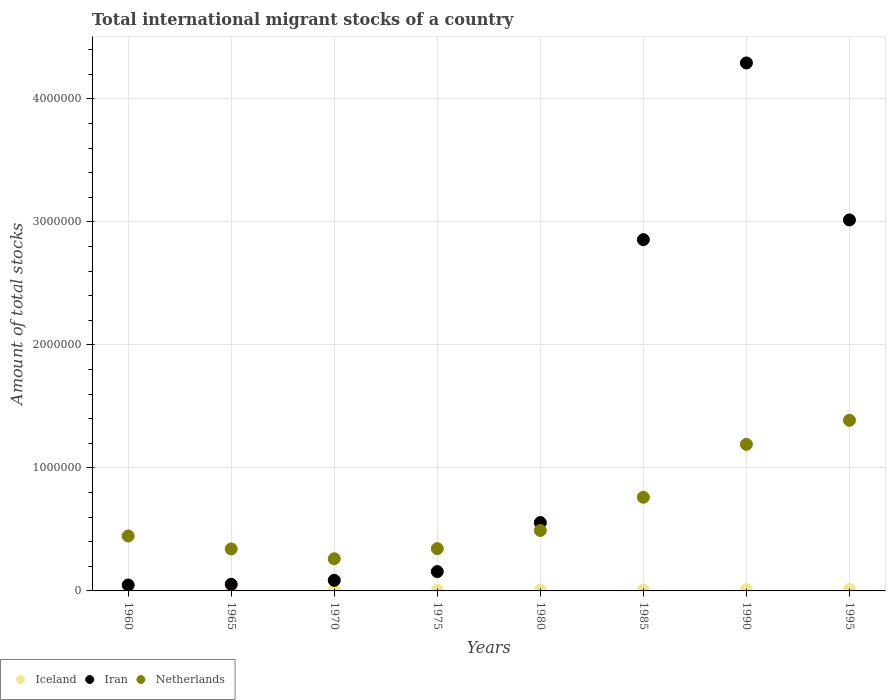What is the amount of total stocks in in Iran in 1995?
Keep it short and to the point. 3.02e+06. Across all years, what is the maximum amount of total stocks in in Iran?
Your response must be concise. 4.29e+06. Across all years, what is the minimum amount of total stocks in in Iran?
Provide a succinct answer. 4.84e+04. What is the total amount of total stocks in in Netherlands in the graph?
Your response must be concise. 5.22e+06. What is the difference between the amount of total stocks in in Netherlands in 1980 and that in 1990?
Make the answer very short. -7.01e+05. What is the difference between the amount of total stocks in in Netherlands in 1975 and the amount of total stocks in in Iran in 1980?
Offer a terse response. -2.12e+05. What is the average amount of total stocks in in Iceland per year?
Give a very brief answer. 6404.88. In the year 1985, what is the difference between the amount of total stocks in in Netherlands and amount of total stocks in in Iceland?
Keep it short and to the point. 7.54e+05. In how many years, is the amount of total stocks in in Iceland greater than 2800000?
Your answer should be very brief. 0. What is the ratio of the amount of total stocks in in Iran in 1975 to that in 1995?
Your answer should be very brief. 0.05. What is the difference between the highest and the second highest amount of total stocks in in Netherlands?
Provide a short and direct response. 1.95e+05. What is the difference between the highest and the lowest amount of total stocks in in Iran?
Offer a terse response. 4.24e+06. Is the sum of the amount of total stocks in in Iran in 1960 and 1995 greater than the maximum amount of total stocks in in Iceland across all years?
Offer a terse response. Yes. Is it the case that in every year, the sum of the amount of total stocks in in Iceland and amount of total stocks in in Netherlands  is greater than the amount of total stocks in in Iran?
Make the answer very short. No. Does the amount of total stocks in in Iceland monotonically increase over the years?
Your answer should be very brief. Yes. Is the amount of total stocks in in Iceland strictly greater than the amount of total stocks in in Iran over the years?
Give a very brief answer. No. How many dotlines are there?
Ensure brevity in your answer.  3. How many years are there in the graph?
Give a very brief answer. 8. Are the values on the major ticks of Y-axis written in scientific E-notation?
Your response must be concise. No. Does the graph contain grids?
Keep it short and to the point. Yes. Where does the legend appear in the graph?
Make the answer very short. Bottom left. How many legend labels are there?
Your answer should be compact. 3. How are the legend labels stacked?
Provide a succinct answer. Horizontal. What is the title of the graph?
Your answer should be very brief. Total international migrant stocks of a country. What is the label or title of the X-axis?
Your answer should be compact. Years. What is the label or title of the Y-axis?
Make the answer very short. Amount of total stocks. What is the Amount of total stocks of Iceland in 1960?
Provide a short and direct response. 3317. What is the Amount of total stocks in Iran in 1960?
Make the answer very short. 4.84e+04. What is the Amount of total stocks of Netherlands in 1960?
Your answer should be compact. 4.47e+05. What is the Amount of total stocks of Iceland in 1965?
Your answer should be compact. 4515. What is the Amount of total stocks in Iran in 1965?
Make the answer very short. 5.38e+04. What is the Amount of total stocks of Netherlands in 1965?
Your response must be concise. 3.42e+05. What is the Amount of total stocks in Iceland in 1970?
Your answer should be very brief. 4914. What is the Amount of total stocks in Iran in 1970?
Your response must be concise. 8.62e+04. What is the Amount of total stocks of Netherlands in 1970?
Keep it short and to the point. 2.61e+05. What is the Amount of total stocks of Iceland in 1975?
Provide a succinct answer. 5279. What is the Amount of total stocks in Iran in 1975?
Provide a succinct answer. 1.57e+05. What is the Amount of total stocks of Netherlands in 1975?
Your answer should be very brief. 3.44e+05. What is the Amount of total stocks of Iceland in 1980?
Offer a very short reply. 5765. What is the Amount of total stocks in Iran in 1980?
Make the answer very short. 5.55e+05. What is the Amount of total stocks in Netherlands in 1980?
Provide a succinct answer. 4.91e+05. What is the Amount of total stocks of Iceland in 1985?
Ensure brevity in your answer.  7098. What is the Amount of total stocks of Iran in 1985?
Offer a very short reply. 2.86e+06. What is the Amount of total stocks of Netherlands in 1985?
Offer a terse response. 7.61e+05. What is the Amount of total stocks of Iceland in 1990?
Give a very brief answer. 9584. What is the Amount of total stocks in Iran in 1990?
Make the answer very short. 4.29e+06. What is the Amount of total stocks of Netherlands in 1990?
Make the answer very short. 1.19e+06. What is the Amount of total stocks of Iceland in 1995?
Keep it short and to the point. 1.08e+04. What is the Amount of total stocks of Iran in 1995?
Provide a succinct answer. 3.02e+06. What is the Amount of total stocks in Netherlands in 1995?
Your answer should be compact. 1.39e+06. Across all years, what is the maximum Amount of total stocks in Iceland?
Offer a very short reply. 1.08e+04. Across all years, what is the maximum Amount of total stocks in Iran?
Give a very brief answer. 4.29e+06. Across all years, what is the maximum Amount of total stocks in Netherlands?
Your answer should be compact. 1.39e+06. Across all years, what is the minimum Amount of total stocks of Iceland?
Offer a very short reply. 3317. Across all years, what is the minimum Amount of total stocks in Iran?
Offer a terse response. 4.84e+04. Across all years, what is the minimum Amount of total stocks of Netherlands?
Your answer should be compact. 2.61e+05. What is the total Amount of total stocks in Iceland in the graph?
Your answer should be compact. 5.12e+04. What is the total Amount of total stocks in Iran in the graph?
Keep it short and to the point. 1.11e+07. What is the total Amount of total stocks in Netherlands in the graph?
Offer a terse response. 5.22e+06. What is the difference between the Amount of total stocks of Iceland in 1960 and that in 1965?
Make the answer very short. -1198. What is the difference between the Amount of total stocks in Iran in 1960 and that in 1965?
Your response must be concise. -5387. What is the difference between the Amount of total stocks in Netherlands in 1960 and that in 1965?
Keep it short and to the point. 1.05e+05. What is the difference between the Amount of total stocks in Iceland in 1960 and that in 1970?
Keep it short and to the point. -1597. What is the difference between the Amount of total stocks of Iran in 1960 and that in 1970?
Provide a succinct answer. -3.78e+04. What is the difference between the Amount of total stocks in Netherlands in 1960 and that in 1970?
Make the answer very short. 1.85e+05. What is the difference between the Amount of total stocks of Iceland in 1960 and that in 1975?
Your response must be concise. -1962. What is the difference between the Amount of total stocks of Iran in 1960 and that in 1975?
Your answer should be very brief. -1.09e+05. What is the difference between the Amount of total stocks in Netherlands in 1960 and that in 1975?
Ensure brevity in your answer.  1.03e+05. What is the difference between the Amount of total stocks of Iceland in 1960 and that in 1980?
Offer a very short reply. -2448. What is the difference between the Amount of total stocks in Iran in 1960 and that in 1980?
Your answer should be very brief. -5.07e+05. What is the difference between the Amount of total stocks in Netherlands in 1960 and that in 1980?
Your response must be concise. -4.44e+04. What is the difference between the Amount of total stocks in Iceland in 1960 and that in 1985?
Your response must be concise. -3781. What is the difference between the Amount of total stocks of Iran in 1960 and that in 1985?
Provide a succinct answer. -2.81e+06. What is the difference between the Amount of total stocks in Netherlands in 1960 and that in 1985?
Your answer should be very brief. -3.15e+05. What is the difference between the Amount of total stocks in Iceland in 1960 and that in 1990?
Offer a very short reply. -6267. What is the difference between the Amount of total stocks in Iran in 1960 and that in 1990?
Ensure brevity in your answer.  -4.24e+06. What is the difference between the Amount of total stocks in Netherlands in 1960 and that in 1990?
Provide a succinct answer. -7.45e+05. What is the difference between the Amount of total stocks in Iceland in 1960 and that in 1995?
Keep it short and to the point. -7450. What is the difference between the Amount of total stocks in Iran in 1960 and that in 1995?
Keep it short and to the point. -2.97e+06. What is the difference between the Amount of total stocks in Netherlands in 1960 and that in 1995?
Give a very brief answer. -9.40e+05. What is the difference between the Amount of total stocks in Iceland in 1965 and that in 1970?
Your answer should be compact. -399. What is the difference between the Amount of total stocks of Iran in 1965 and that in 1970?
Offer a terse response. -3.24e+04. What is the difference between the Amount of total stocks of Netherlands in 1965 and that in 1970?
Keep it short and to the point. 8.03e+04. What is the difference between the Amount of total stocks in Iceland in 1965 and that in 1975?
Your response must be concise. -764. What is the difference between the Amount of total stocks in Iran in 1965 and that in 1975?
Provide a short and direct response. -1.03e+05. What is the difference between the Amount of total stocks of Netherlands in 1965 and that in 1975?
Offer a terse response. -2069. What is the difference between the Amount of total stocks in Iceland in 1965 and that in 1980?
Give a very brief answer. -1250. What is the difference between the Amount of total stocks of Iran in 1965 and that in 1980?
Ensure brevity in your answer.  -5.02e+05. What is the difference between the Amount of total stocks of Netherlands in 1965 and that in 1980?
Make the answer very short. -1.49e+05. What is the difference between the Amount of total stocks in Iceland in 1965 and that in 1985?
Provide a short and direct response. -2583. What is the difference between the Amount of total stocks in Iran in 1965 and that in 1985?
Your answer should be very brief. -2.80e+06. What is the difference between the Amount of total stocks of Netherlands in 1965 and that in 1985?
Ensure brevity in your answer.  -4.20e+05. What is the difference between the Amount of total stocks in Iceland in 1965 and that in 1990?
Your answer should be very brief. -5069. What is the difference between the Amount of total stocks in Iran in 1965 and that in 1990?
Your answer should be very brief. -4.24e+06. What is the difference between the Amount of total stocks in Netherlands in 1965 and that in 1990?
Offer a terse response. -8.50e+05. What is the difference between the Amount of total stocks in Iceland in 1965 and that in 1995?
Make the answer very short. -6252. What is the difference between the Amount of total stocks in Iran in 1965 and that in 1995?
Give a very brief answer. -2.96e+06. What is the difference between the Amount of total stocks of Netherlands in 1965 and that in 1995?
Provide a succinct answer. -1.05e+06. What is the difference between the Amount of total stocks in Iceland in 1970 and that in 1975?
Offer a very short reply. -365. What is the difference between the Amount of total stocks of Iran in 1970 and that in 1975?
Offer a very short reply. -7.10e+04. What is the difference between the Amount of total stocks of Netherlands in 1970 and that in 1975?
Offer a terse response. -8.24e+04. What is the difference between the Amount of total stocks of Iceland in 1970 and that in 1980?
Your answer should be compact. -851. What is the difference between the Amount of total stocks in Iran in 1970 and that in 1980?
Your answer should be compact. -4.69e+05. What is the difference between the Amount of total stocks in Netherlands in 1970 and that in 1980?
Keep it short and to the point. -2.30e+05. What is the difference between the Amount of total stocks of Iceland in 1970 and that in 1985?
Ensure brevity in your answer.  -2184. What is the difference between the Amount of total stocks in Iran in 1970 and that in 1985?
Provide a short and direct response. -2.77e+06. What is the difference between the Amount of total stocks of Netherlands in 1970 and that in 1985?
Provide a succinct answer. -5.00e+05. What is the difference between the Amount of total stocks in Iceland in 1970 and that in 1990?
Provide a short and direct response. -4670. What is the difference between the Amount of total stocks in Iran in 1970 and that in 1990?
Offer a very short reply. -4.21e+06. What is the difference between the Amount of total stocks in Netherlands in 1970 and that in 1990?
Your answer should be very brief. -9.30e+05. What is the difference between the Amount of total stocks of Iceland in 1970 and that in 1995?
Ensure brevity in your answer.  -5853. What is the difference between the Amount of total stocks in Iran in 1970 and that in 1995?
Keep it short and to the point. -2.93e+06. What is the difference between the Amount of total stocks in Netherlands in 1970 and that in 1995?
Ensure brevity in your answer.  -1.13e+06. What is the difference between the Amount of total stocks of Iceland in 1975 and that in 1980?
Your answer should be very brief. -486. What is the difference between the Amount of total stocks of Iran in 1975 and that in 1980?
Offer a terse response. -3.98e+05. What is the difference between the Amount of total stocks in Netherlands in 1975 and that in 1980?
Offer a terse response. -1.47e+05. What is the difference between the Amount of total stocks in Iceland in 1975 and that in 1985?
Your response must be concise. -1819. What is the difference between the Amount of total stocks of Iran in 1975 and that in 1985?
Give a very brief answer. -2.70e+06. What is the difference between the Amount of total stocks of Netherlands in 1975 and that in 1985?
Your response must be concise. -4.18e+05. What is the difference between the Amount of total stocks of Iceland in 1975 and that in 1990?
Offer a very short reply. -4305. What is the difference between the Amount of total stocks in Iran in 1975 and that in 1990?
Offer a terse response. -4.13e+06. What is the difference between the Amount of total stocks in Netherlands in 1975 and that in 1990?
Ensure brevity in your answer.  -8.48e+05. What is the difference between the Amount of total stocks in Iceland in 1975 and that in 1995?
Offer a very short reply. -5488. What is the difference between the Amount of total stocks of Iran in 1975 and that in 1995?
Provide a succinct answer. -2.86e+06. What is the difference between the Amount of total stocks in Netherlands in 1975 and that in 1995?
Your answer should be very brief. -1.04e+06. What is the difference between the Amount of total stocks in Iceland in 1980 and that in 1985?
Give a very brief answer. -1333. What is the difference between the Amount of total stocks in Iran in 1980 and that in 1985?
Keep it short and to the point. -2.30e+06. What is the difference between the Amount of total stocks of Netherlands in 1980 and that in 1985?
Ensure brevity in your answer.  -2.70e+05. What is the difference between the Amount of total stocks of Iceland in 1980 and that in 1990?
Keep it short and to the point. -3819. What is the difference between the Amount of total stocks in Iran in 1980 and that in 1990?
Offer a terse response. -3.74e+06. What is the difference between the Amount of total stocks in Netherlands in 1980 and that in 1990?
Offer a very short reply. -7.01e+05. What is the difference between the Amount of total stocks of Iceland in 1980 and that in 1995?
Your answer should be compact. -5002. What is the difference between the Amount of total stocks in Iran in 1980 and that in 1995?
Offer a terse response. -2.46e+06. What is the difference between the Amount of total stocks of Netherlands in 1980 and that in 1995?
Provide a succinct answer. -8.96e+05. What is the difference between the Amount of total stocks in Iceland in 1985 and that in 1990?
Your answer should be very brief. -2486. What is the difference between the Amount of total stocks in Iran in 1985 and that in 1990?
Your answer should be compact. -1.44e+06. What is the difference between the Amount of total stocks of Netherlands in 1985 and that in 1990?
Your answer should be compact. -4.30e+05. What is the difference between the Amount of total stocks in Iceland in 1985 and that in 1995?
Make the answer very short. -3669. What is the difference between the Amount of total stocks of Iran in 1985 and that in 1995?
Ensure brevity in your answer.  -1.60e+05. What is the difference between the Amount of total stocks of Netherlands in 1985 and that in 1995?
Your answer should be very brief. -6.25e+05. What is the difference between the Amount of total stocks in Iceland in 1990 and that in 1995?
Keep it short and to the point. -1183. What is the difference between the Amount of total stocks in Iran in 1990 and that in 1995?
Keep it short and to the point. 1.28e+06. What is the difference between the Amount of total stocks of Netherlands in 1990 and that in 1995?
Give a very brief answer. -1.95e+05. What is the difference between the Amount of total stocks of Iceland in 1960 and the Amount of total stocks of Iran in 1965?
Make the answer very short. -5.04e+04. What is the difference between the Amount of total stocks of Iceland in 1960 and the Amount of total stocks of Netherlands in 1965?
Your answer should be compact. -3.38e+05. What is the difference between the Amount of total stocks of Iran in 1960 and the Amount of total stocks of Netherlands in 1965?
Your answer should be compact. -2.93e+05. What is the difference between the Amount of total stocks of Iceland in 1960 and the Amount of total stocks of Iran in 1970?
Your answer should be very brief. -8.28e+04. What is the difference between the Amount of total stocks of Iceland in 1960 and the Amount of total stocks of Netherlands in 1970?
Your answer should be very brief. -2.58e+05. What is the difference between the Amount of total stocks in Iran in 1960 and the Amount of total stocks in Netherlands in 1970?
Give a very brief answer. -2.13e+05. What is the difference between the Amount of total stocks in Iceland in 1960 and the Amount of total stocks in Iran in 1975?
Make the answer very short. -1.54e+05. What is the difference between the Amount of total stocks in Iceland in 1960 and the Amount of total stocks in Netherlands in 1975?
Your answer should be very brief. -3.40e+05. What is the difference between the Amount of total stocks of Iran in 1960 and the Amount of total stocks of Netherlands in 1975?
Offer a very short reply. -2.95e+05. What is the difference between the Amount of total stocks of Iceland in 1960 and the Amount of total stocks of Iran in 1980?
Provide a short and direct response. -5.52e+05. What is the difference between the Amount of total stocks in Iceland in 1960 and the Amount of total stocks in Netherlands in 1980?
Give a very brief answer. -4.88e+05. What is the difference between the Amount of total stocks of Iran in 1960 and the Amount of total stocks of Netherlands in 1980?
Your answer should be compact. -4.43e+05. What is the difference between the Amount of total stocks of Iceland in 1960 and the Amount of total stocks of Iran in 1985?
Your answer should be very brief. -2.85e+06. What is the difference between the Amount of total stocks in Iceland in 1960 and the Amount of total stocks in Netherlands in 1985?
Ensure brevity in your answer.  -7.58e+05. What is the difference between the Amount of total stocks of Iran in 1960 and the Amount of total stocks of Netherlands in 1985?
Your response must be concise. -7.13e+05. What is the difference between the Amount of total stocks in Iceland in 1960 and the Amount of total stocks in Iran in 1990?
Your answer should be very brief. -4.29e+06. What is the difference between the Amount of total stocks of Iceland in 1960 and the Amount of total stocks of Netherlands in 1990?
Offer a terse response. -1.19e+06. What is the difference between the Amount of total stocks in Iran in 1960 and the Amount of total stocks in Netherlands in 1990?
Provide a short and direct response. -1.14e+06. What is the difference between the Amount of total stocks in Iceland in 1960 and the Amount of total stocks in Iran in 1995?
Your answer should be very brief. -3.01e+06. What is the difference between the Amount of total stocks in Iceland in 1960 and the Amount of total stocks in Netherlands in 1995?
Provide a short and direct response. -1.38e+06. What is the difference between the Amount of total stocks in Iran in 1960 and the Amount of total stocks in Netherlands in 1995?
Offer a very short reply. -1.34e+06. What is the difference between the Amount of total stocks of Iceland in 1965 and the Amount of total stocks of Iran in 1970?
Make the answer very short. -8.16e+04. What is the difference between the Amount of total stocks in Iceland in 1965 and the Amount of total stocks in Netherlands in 1970?
Ensure brevity in your answer.  -2.57e+05. What is the difference between the Amount of total stocks of Iran in 1965 and the Amount of total stocks of Netherlands in 1970?
Your answer should be very brief. -2.08e+05. What is the difference between the Amount of total stocks in Iceland in 1965 and the Amount of total stocks in Iran in 1975?
Offer a terse response. -1.53e+05. What is the difference between the Amount of total stocks of Iceland in 1965 and the Amount of total stocks of Netherlands in 1975?
Give a very brief answer. -3.39e+05. What is the difference between the Amount of total stocks of Iran in 1965 and the Amount of total stocks of Netherlands in 1975?
Your response must be concise. -2.90e+05. What is the difference between the Amount of total stocks of Iceland in 1965 and the Amount of total stocks of Iran in 1980?
Your answer should be compact. -5.51e+05. What is the difference between the Amount of total stocks in Iceland in 1965 and the Amount of total stocks in Netherlands in 1980?
Your answer should be very brief. -4.86e+05. What is the difference between the Amount of total stocks of Iran in 1965 and the Amount of total stocks of Netherlands in 1980?
Provide a short and direct response. -4.37e+05. What is the difference between the Amount of total stocks of Iceland in 1965 and the Amount of total stocks of Iran in 1985?
Your answer should be very brief. -2.85e+06. What is the difference between the Amount of total stocks in Iceland in 1965 and the Amount of total stocks in Netherlands in 1985?
Provide a succinct answer. -7.57e+05. What is the difference between the Amount of total stocks of Iran in 1965 and the Amount of total stocks of Netherlands in 1985?
Your answer should be compact. -7.08e+05. What is the difference between the Amount of total stocks in Iceland in 1965 and the Amount of total stocks in Iran in 1990?
Your answer should be very brief. -4.29e+06. What is the difference between the Amount of total stocks of Iceland in 1965 and the Amount of total stocks of Netherlands in 1990?
Provide a succinct answer. -1.19e+06. What is the difference between the Amount of total stocks of Iran in 1965 and the Amount of total stocks of Netherlands in 1990?
Give a very brief answer. -1.14e+06. What is the difference between the Amount of total stocks of Iceland in 1965 and the Amount of total stocks of Iran in 1995?
Offer a terse response. -3.01e+06. What is the difference between the Amount of total stocks in Iceland in 1965 and the Amount of total stocks in Netherlands in 1995?
Your response must be concise. -1.38e+06. What is the difference between the Amount of total stocks in Iran in 1965 and the Amount of total stocks in Netherlands in 1995?
Provide a succinct answer. -1.33e+06. What is the difference between the Amount of total stocks in Iceland in 1970 and the Amount of total stocks in Iran in 1975?
Keep it short and to the point. -1.52e+05. What is the difference between the Amount of total stocks in Iceland in 1970 and the Amount of total stocks in Netherlands in 1975?
Provide a short and direct response. -3.39e+05. What is the difference between the Amount of total stocks of Iran in 1970 and the Amount of total stocks of Netherlands in 1975?
Make the answer very short. -2.58e+05. What is the difference between the Amount of total stocks in Iceland in 1970 and the Amount of total stocks in Iran in 1980?
Your answer should be very brief. -5.51e+05. What is the difference between the Amount of total stocks in Iceland in 1970 and the Amount of total stocks in Netherlands in 1980?
Provide a short and direct response. -4.86e+05. What is the difference between the Amount of total stocks in Iran in 1970 and the Amount of total stocks in Netherlands in 1980?
Your answer should be very brief. -4.05e+05. What is the difference between the Amount of total stocks in Iceland in 1970 and the Amount of total stocks in Iran in 1985?
Your response must be concise. -2.85e+06. What is the difference between the Amount of total stocks in Iceland in 1970 and the Amount of total stocks in Netherlands in 1985?
Ensure brevity in your answer.  -7.57e+05. What is the difference between the Amount of total stocks of Iran in 1970 and the Amount of total stocks of Netherlands in 1985?
Your answer should be very brief. -6.75e+05. What is the difference between the Amount of total stocks of Iceland in 1970 and the Amount of total stocks of Iran in 1990?
Keep it short and to the point. -4.29e+06. What is the difference between the Amount of total stocks in Iceland in 1970 and the Amount of total stocks in Netherlands in 1990?
Your answer should be compact. -1.19e+06. What is the difference between the Amount of total stocks of Iran in 1970 and the Amount of total stocks of Netherlands in 1990?
Your response must be concise. -1.11e+06. What is the difference between the Amount of total stocks in Iceland in 1970 and the Amount of total stocks in Iran in 1995?
Make the answer very short. -3.01e+06. What is the difference between the Amount of total stocks in Iceland in 1970 and the Amount of total stocks in Netherlands in 1995?
Provide a short and direct response. -1.38e+06. What is the difference between the Amount of total stocks in Iran in 1970 and the Amount of total stocks in Netherlands in 1995?
Your answer should be compact. -1.30e+06. What is the difference between the Amount of total stocks in Iceland in 1975 and the Amount of total stocks in Iran in 1980?
Offer a terse response. -5.50e+05. What is the difference between the Amount of total stocks of Iceland in 1975 and the Amount of total stocks of Netherlands in 1980?
Provide a short and direct response. -4.86e+05. What is the difference between the Amount of total stocks of Iran in 1975 and the Amount of total stocks of Netherlands in 1980?
Provide a short and direct response. -3.34e+05. What is the difference between the Amount of total stocks of Iceland in 1975 and the Amount of total stocks of Iran in 1985?
Keep it short and to the point. -2.85e+06. What is the difference between the Amount of total stocks of Iceland in 1975 and the Amount of total stocks of Netherlands in 1985?
Provide a succinct answer. -7.56e+05. What is the difference between the Amount of total stocks in Iran in 1975 and the Amount of total stocks in Netherlands in 1985?
Make the answer very short. -6.04e+05. What is the difference between the Amount of total stocks of Iceland in 1975 and the Amount of total stocks of Iran in 1990?
Ensure brevity in your answer.  -4.29e+06. What is the difference between the Amount of total stocks in Iceland in 1975 and the Amount of total stocks in Netherlands in 1990?
Give a very brief answer. -1.19e+06. What is the difference between the Amount of total stocks in Iran in 1975 and the Amount of total stocks in Netherlands in 1990?
Your answer should be very brief. -1.03e+06. What is the difference between the Amount of total stocks in Iceland in 1975 and the Amount of total stocks in Iran in 1995?
Your answer should be compact. -3.01e+06. What is the difference between the Amount of total stocks in Iceland in 1975 and the Amount of total stocks in Netherlands in 1995?
Your answer should be very brief. -1.38e+06. What is the difference between the Amount of total stocks of Iran in 1975 and the Amount of total stocks of Netherlands in 1995?
Keep it short and to the point. -1.23e+06. What is the difference between the Amount of total stocks in Iceland in 1980 and the Amount of total stocks in Iran in 1985?
Make the answer very short. -2.85e+06. What is the difference between the Amount of total stocks of Iceland in 1980 and the Amount of total stocks of Netherlands in 1985?
Ensure brevity in your answer.  -7.56e+05. What is the difference between the Amount of total stocks of Iran in 1980 and the Amount of total stocks of Netherlands in 1985?
Your answer should be very brief. -2.06e+05. What is the difference between the Amount of total stocks in Iceland in 1980 and the Amount of total stocks in Iran in 1990?
Provide a succinct answer. -4.29e+06. What is the difference between the Amount of total stocks of Iceland in 1980 and the Amount of total stocks of Netherlands in 1990?
Give a very brief answer. -1.19e+06. What is the difference between the Amount of total stocks in Iran in 1980 and the Amount of total stocks in Netherlands in 1990?
Ensure brevity in your answer.  -6.36e+05. What is the difference between the Amount of total stocks of Iceland in 1980 and the Amount of total stocks of Iran in 1995?
Provide a short and direct response. -3.01e+06. What is the difference between the Amount of total stocks of Iceland in 1980 and the Amount of total stocks of Netherlands in 1995?
Give a very brief answer. -1.38e+06. What is the difference between the Amount of total stocks in Iran in 1980 and the Amount of total stocks in Netherlands in 1995?
Make the answer very short. -8.31e+05. What is the difference between the Amount of total stocks in Iceland in 1985 and the Amount of total stocks in Iran in 1990?
Your answer should be compact. -4.28e+06. What is the difference between the Amount of total stocks in Iceland in 1985 and the Amount of total stocks in Netherlands in 1990?
Provide a short and direct response. -1.18e+06. What is the difference between the Amount of total stocks in Iran in 1985 and the Amount of total stocks in Netherlands in 1990?
Ensure brevity in your answer.  1.66e+06. What is the difference between the Amount of total stocks in Iceland in 1985 and the Amount of total stocks in Iran in 1995?
Keep it short and to the point. -3.01e+06. What is the difference between the Amount of total stocks of Iceland in 1985 and the Amount of total stocks of Netherlands in 1995?
Keep it short and to the point. -1.38e+06. What is the difference between the Amount of total stocks in Iran in 1985 and the Amount of total stocks in Netherlands in 1995?
Ensure brevity in your answer.  1.47e+06. What is the difference between the Amount of total stocks of Iceland in 1990 and the Amount of total stocks of Iran in 1995?
Keep it short and to the point. -3.01e+06. What is the difference between the Amount of total stocks of Iceland in 1990 and the Amount of total stocks of Netherlands in 1995?
Keep it short and to the point. -1.38e+06. What is the difference between the Amount of total stocks of Iran in 1990 and the Amount of total stocks of Netherlands in 1995?
Provide a short and direct response. 2.90e+06. What is the average Amount of total stocks in Iceland per year?
Provide a short and direct response. 6404.88. What is the average Amount of total stocks of Iran per year?
Make the answer very short. 1.38e+06. What is the average Amount of total stocks of Netherlands per year?
Make the answer very short. 6.53e+05. In the year 1960, what is the difference between the Amount of total stocks of Iceland and Amount of total stocks of Iran?
Provide a succinct answer. -4.51e+04. In the year 1960, what is the difference between the Amount of total stocks in Iceland and Amount of total stocks in Netherlands?
Your response must be concise. -4.43e+05. In the year 1960, what is the difference between the Amount of total stocks in Iran and Amount of total stocks in Netherlands?
Provide a short and direct response. -3.98e+05. In the year 1965, what is the difference between the Amount of total stocks in Iceland and Amount of total stocks in Iran?
Offer a terse response. -4.92e+04. In the year 1965, what is the difference between the Amount of total stocks in Iceland and Amount of total stocks in Netherlands?
Your answer should be compact. -3.37e+05. In the year 1965, what is the difference between the Amount of total stocks of Iran and Amount of total stocks of Netherlands?
Offer a terse response. -2.88e+05. In the year 1970, what is the difference between the Amount of total stocks in Iceland and Amount of total stocks in Iran?
Your answer should be compact. -8.13e+04. In the year 1970, what is the difference between the Amount of total stocks of Iceland and Amount of total stocks of Netherlands?
Keep it short and to the point. -2.56e+05. In the year 1970, what is the difference between the Amount of total stocks of Iran and Amount of total stocks of Netherlands?
Ensure brevity in your answer.  -1.75e+05. In the year 1975, what is the difference between the Amount of total stocks in Iceland and Amount of total stocks in Iran?
Offer a terse response. -1.52e+05. In the year 1975, what is the difference between the Amount of total stocks in Iceland and Amount of total stocks in Netherlands?
Provide a short and direct response. -3.38e+05. In the year 1975, what is the difference between the Amount of total stocks of Iran and Amount of total stocks of Netherlands?
Make the answer very short. -1.87e+05. In the year 1980, what is the difference between the Amount of total stocks of Iceland and Amount of total stocks of Iran?
Offer a terse response. -5.50e+05. In the year 1980, what is the difference between the Amount of total stocks of Iceland and Amount of total stocks of Netherlands?
Your response must be concise. -4.85e+05. In the year 1980, what is the difference between the Amount of total stocks of Iran and Amount of total stocks of Netherlands?
Provide a succinct answer. 6.45e+04. In the year 1985, what is the difference between the Amount of total stocks in Iceland and Amount of total stocks in Iran?
Provide a short and direct response. -2.85e+06. In the year 1985, what is the difference between the Amount of total stocks of Iceland and Amount of total stocks of Netherlands?
Offer a very short reply. -7.54e+05. In the year 1985, what is the difference between the Amount of total stocks of Iran and Amount of total stocks of Netherlands?
Offer a terse response. 2.09e+06. In the year 1990, what is the difference between the Amount of total stocks of Iceland and Amount of total stocks of Iran?
Keep it short and to the point. -4.28e+06. In the year 1990, what is the difference between the Amount of total stocks of Iceland and Amount of total stocks of Netherlands?
Keep it short and to the point. -1.18e+06. In the year 1990, what is the difference between the Amount of total stocks in Iran and Amount of total stocks in Netherlands?
Your answer should be compact. 3.10e+06. In the year 1995, what is the difference between the Amount of total stocks in Iceland and Amount of total stocks in Iran?
Offer a terse response. -3.00e+06. In the year 1995, what is the difference between the Amount of total stocks of Iceland and Amount of total stocks of Netherlands?
Provide a succinct answer. -1.38e+06. In the year 1995, what is the difference between the Amount of total stocks in Iran and Amount of total stocks in Netherlands?
Ensure brevity in your answer.  1.63e+06. What is the ratio of the Amount of total stocks of Iceland in 1960 to that in 1965?
Ensure brevity in your answer.  0.73. What is the ratio of the Amount of total stocks of Iran in 1960 to that in 1965?
Your response must be concise. 0.9. What is the ratio of the Amount of total stocks of Netherlands in 1960 to that in 1965?
Keep it short and to the point. 1.31. What is the ratio of the Amount of total stocks of Iceland in 1960 to that in 1970?
Provide a short and direct response. 0.68. What is the ratio of the Amount of total stocks of Iran in 1960 to that in 1970?
Provide a short and direct response. 0.56. What is the ratio of the Amount of total stocks of Netherlands in 1960 to that in 1970?
Give a very brief answer. 1.71. What is the ratio of the Amount of total stocks of Iceland in 1960 to that in 1975?
Provide a succinct answer. 0.63. What is the ratio of the Amount of total stocks in Iran in 1960 to that in 1975?
Ensure brevity in your answer.  0.31. What is the ratio of the Amount of total stocks in Netherlands in 1960 to that in 1975?
Make the answer very short. 1.3. What is the ratio of the Amount of total stocks in Iceland in 1960 to that in 1980?
Your answer should be very brief. 0.58. What is the ratio of the Amount of total stocks of Iran in 1960 to that in 1980?
Your response must be concise. 0.09. What is the ratio of the Amount of total stocks in Netherlands in 1960 to that in 1980?
Keep it short and to the point. 0.91. What is the ratio of the Amount of total stocks of Iceland in 1960 to that in 1985?
Make the answer very short. 0.47. What is the ratio of the Amount of total stocks in Iran in 1960 to that in 1985?
Your answer should be very brief. 0.02. What is the ratio of the Amount of total stocks of Netherlands in 1960 to that in 1985?
Your answer should be very brief. 0.59. What is the ratio of the Amount of total stocks of Iceland in 1960 to that in 1990?
Provide a short and direct response. 0.35. What is the ratio of the Amount of total stocks in Iran in 1960 to that in 1990?
Provide a succinct answer. 0.01. What is the ratio of the Amount of total stocks in Netherlands in 1960 to that in 1990?
Make the answer very short. 0.37. What is the ratio of the Amount of total stocks in Iceland in 1960 to that in 1995?
Ensure brevity in your answer.  0.31. What is the ratio of the Amount of total stocks in Iran in 1960 to that in 1995?
Offer a terse response. 0.02. What is the ratio of the Amount of total stocks in Netherlands in 1960 to that in 1995?
Your answer should be compact. 0.32. What is the ratio of the Amount of total stocks of Iceland in 1965 to that in 1970?
Your answer should be compact. 0.92. What is the ratio of the Amount of total stocks of Iran in 1965 to that in 1970?
Keep it short and to the point. 0.62. What is the ratio of the Amount of total stocks of Netherlands in 1965 to that in 1970?
Your response must be concise. 1.31. What is the ratio of the Amount of total stocks of Iceland in 1965 to that in 1975?
Your answer should be very brief. 0.86. What is the ratio of the Amount of total stocks of Iran in 1965 to that in 1975?
Provide a succinct answer. 0.34. What is the ratio of the Amount of total stocks in Netherlands in 1965 to that in 1975?
Your response must be concise. 0.99. What is the ratio of the Amount of total stocks of Iceland in 1965 to that in 1980?
Offer a terse response. 0.78. What is the ratio of the Amount of total stocks in Iran in 1965 to that in 1980?
Offer a terse response. 0.1. What is the ratio of the Amount of total stocks in Netherlands in 1965 to that in 1980?
Keep it short and to the point. 0.7. What is the ratio of the Amount of total stocks of Iceland in 1965 to that in 1985?
Ensure brevity in your answer.  0.64. What is the ratio of the Amount of total stocks in Iran in 1965 to that in 1985?
Provide a succinct answer. 0.02. What is the ratio of the Amount of total stocks in Netherlands in 1965 to that in 1985?
Your response must be concise. 0.45. What is the ratio of the Amount of total stocks of Iceland in 1965 to that in 1990?
Keep it short and to the point. 0.47. What is the ratio of the Amount of total stocks in Iran in 1965 to that in 1990?
Give a very brief answer. 0.01. What is the ratio of the Amount of total stocks in Netherlands in 1965 to that in 1990?
Ensure brevity in your answer.  0.29. What is the ratio of the Amount of total stocks in Iceland in 1965 to that in 1995?
Offer a very short reply. 0.42. What is the ratio of the Amount of total stocks of Iran in 1965 to that in 1995?
Keep it short and to the point. 0.02. What is the ratio of the Amount of total stocks of Netherlands in 1965 to that in 1995?
Give a very brief answer. 0.25. What is the ratio of the Amount of total stocks in Iceland in 1970 to that in 1975?
Offer a terse response. 0.93. What is the ratio of the Amount of total stocks of Iran in 1970 to that in 1975?
Provide a succinct answer. 0.55. What is the ratio of the Amount of total stocks of Netherlands in 1970 to that in 1975?
Your response must be concise. 0.76. What is the ratio of the Amount of total stocks of Iceland in 1970 to that in 1980?
Your response must be concise. 0.85. What is the ratio of the Amount of total stocks of Iran in 1970 to that in 1980?
Ensure brevity in your answer.  0.16. What is the ratio of the Amount of total stocks in Netherlands in 1970 to that in 1980?
Keep it short and to the point. 0.53. What is the ratio of the Amount of total stocks of Iceland in 1970 to that in 1985?
Give a very brief answer. 0.69. What is the ratio of the Amount of total stocks in Iran in 1970 to that in 1985?
Offer a very short reply. 0.03. What is the ratio of the Amount of total stocks in Netherlands in 1970 to that in 1985?
Your answer should be compact. 0.34. What is the ratio of the Amount of total stocks of Iceland in 1970 to that in 1990?
Provide a succinct answer. 0.51. What is the ratio of the Amount of total stocks in Iran in 1970 to that in 1990?
Provide a succinct answer. 0.02. What is the ratio of the Amount of total stocks of Netherlands in 1970 to that in 1990?
Give a very brief answer. 0.22. What is the ratio of the Amount of total stocks of Iceland in 1970 to that in 1995?
Keep it short and to the point. 0.46. What is the ratio of the Amount of total stocks in Iran in 1970 to that in 1995?
Your answer should be very brief. 0.03. What is the ratio of the Amount of total stocks of Netherlands in 1970 to that in 1995?
Keep it short and to the point. 0.19. What is the ratio of the Amount of total stocks of Iceland in 1975 to that in 1980?
Offer a very short reply. 0.92. What is the ratio of the Amount of total stocks of Iran in 1975 to that in 1980?
Your answer should be compact. 0.28. What is the ratio of the Amount of total stocks in Netherlands in 1975 to that in 1980?
Ensure brevity in your answer.  0.7. What is the ratio of the Amount of total stocks of Iceland in 1975 to that in 1985?
Offer a very short reply. 0.74. What is the ratio of the Amount of total stocks of Iran in 1975 to that in 1985?
Ensure brevity in your answer.  0.06. What is the ratio of the Amount of total stocks of Netherlands in 1975 to that in 1985?
Your response must be concise. 0.45. What is the ratio of the Amount of total stocks of Iceland in 1975 to that in 1990?
Offer a terse response. 0.55. What is the ratio of the Amount of total stocks in Iran in 1975 to that in 1990?
Your answer should be compact. 0.04. What is the ratio of the Amount of total stocks in Netherlands in 1975 to that in 1990?
Your answer should be very brief. 0.29. What is the ratio of the Amount of total stocks in Iceland in 1975 to that in 1995?
Ensure brevity in your answer.  0.49. What is the ratio of the Amount of total stocks in Iran in 1975 to that in 1995?
Provide a succinct answer. 0.05. What is the ratio of the Amount of total stocks in Netherlands in 1975 to that in 1995?
Provide a short and direct response. 0.25. What is the ratio of the Amount of total stocks of Iceland in 1980 to that in 1985?
Ensure brevity in your answer.  0.81. What is the ratio of the Amount of total stocks of Iran in 1980 to that in 1985?
Offer a terse response. 0.19. What is the ratio of the Amount of total stocks in Netherlands in 1980 to that in 1985?
Give a very brief answer. 0.64. What is the ratio of the Amount of total stocks of Iceland in 1980 to that in 1990?
Keep it short and to the point. 0.6. What is the ratio of the Amount of total stocks of Iran in 1980 to that in 1990?
Give a very brief answer. 0.13. What is the ratio of the Amount of total stocks in Netherlands in 1980 to that in 1990?
Offer a very short reply. 0.41. What is the ratio of the Amount of total stocks in Iceland in 1980 to that in 1995?
Your response must be concise. 0.54. What is the ratio of the Amount of total stocks in Iran in 1980 to that in 1995?
Offer a terse response. 0.18. What is the ratio of the Amount of total stocks of Netherlands in 1980 to that in 1995?
Make the answer very short. 0.35. What is the ratio of the Amount of total stocks of Iceland in 1985 to that in 1990?
Offer a terse response. 0.74. What is the ratio of the Amount of total stocks of Iran in 1985 to that in 1990?
Keep it short and to the point. 0.67. What is the ratio of the Amount of total stocks in Netherlands in 1985 to that in 1990?
Provide a succinct answer. 0.64. What is the ratio of the Amount of total stocks in Iceland in 1985 to that in 1995?
Keep it short and to the point. 0.66. What is the ratio of the Amount of total stocks in Iran in 1985 to that in 1995?
Offer a very short reply. 0.95. What is the ratio of the Amount of total stocks in Netherlands in 1985 to that in 1995?
Make the answer very short. 0.55. What is the ratio of the Amount of total stocks of Iceland in 1990 to that in 1995?
Give a very brief answer. 0.89. What is the ratio of the Amount of total stocks of Iran in 1990 to that in 1995?
Offer a very short reply. 1.42. What is the ratio of the Amount of total stocks in Netherlands in 1990 to that in 1995?
Ensure brevity in your answer.  0.86. What is the difference between the highest and the second highest Amount of total stocks of Iceland?
Ensure brevity in your answer.  1183. What is the difference between the highest and the second highest Amount of total stocks of Iran?
Your answer should be compact. 1.28e+06. What is the difference between the highest and the second highest Amount of total stocks of Netherlands?
Your answer should be compact. 1.95e+05. What is the difference between the highest and the lowest Amount of total stocks in Iceland?
Your response must be concise. 7450. What is the difference between the highest and the lowest Amount of total stocks of Iran?
Offer a very short reply. 4.24e+06. What is the difference between the highest and the lowest Amount of total stocks of Netherlands?
Provide a succinct answer. 1.13e+06. 